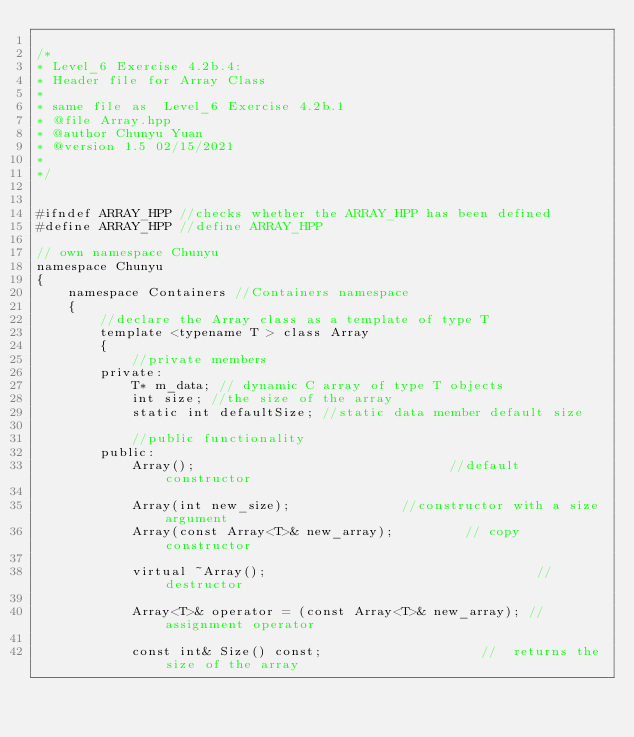<code> <loc_0><loc_0><loc_500><loc_500><_C++_>
/*
* Level_6 Exercise 4.2b.4:
* Header file for Array Class
*
* same file as  Level_6 Exercise 4.2b.1
* @file Array.hpp
* @author Chunyu Yuan
* @version 1.5 02/15/2021
*
*/


#ifndef ARRAY_HPP //checks whether the ARRAY_HPP has been defined
#define ARRAY_HPP //define ARRAY_HPP

// own namespace Chunyu
namespace Chunyu
{
	namespace Containers //Containers namespace 
	{
		//declare the Array class as a template of type T
		template <typename T > class Array
		{
			//private members
		private:
			T* m_data; // dynamic C array of type T objects
			int size; //the size of the array
			static int defaultSize; //static data member default size 

			//public functionality
		public:
			Array();                                //default constructor

			Array(int new_size);              //constructor with a size argument
			Array(const Array<T>& new_array);         // copy constructor

			virtual ~Array();                                  //destructor

			Array<T>& operator = (const Array<T>& new_array); //assignment operator

			const int& Size() const;                    //  returns the size of the array  
</code> 